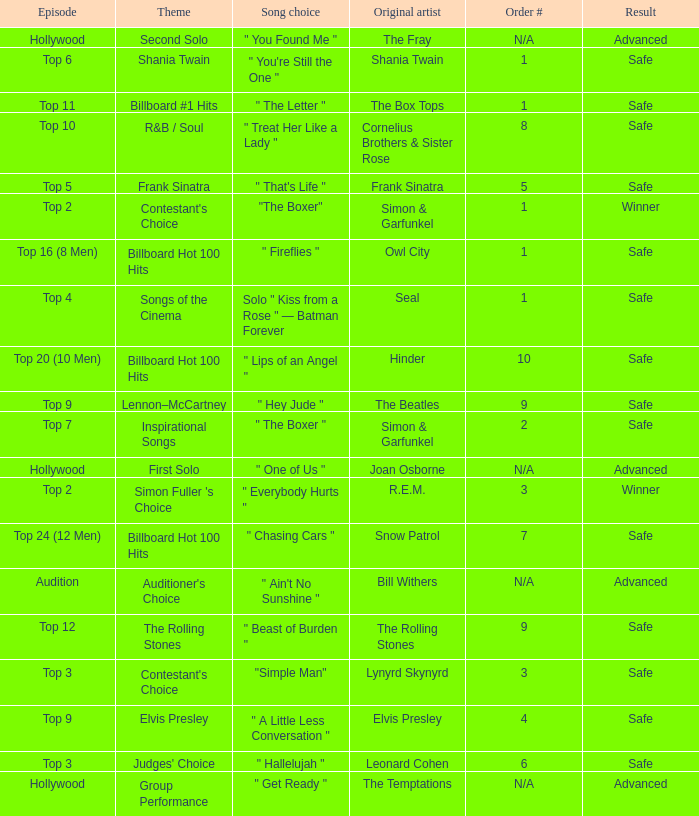The song choice " One of Us " has what themes? First Solo. 